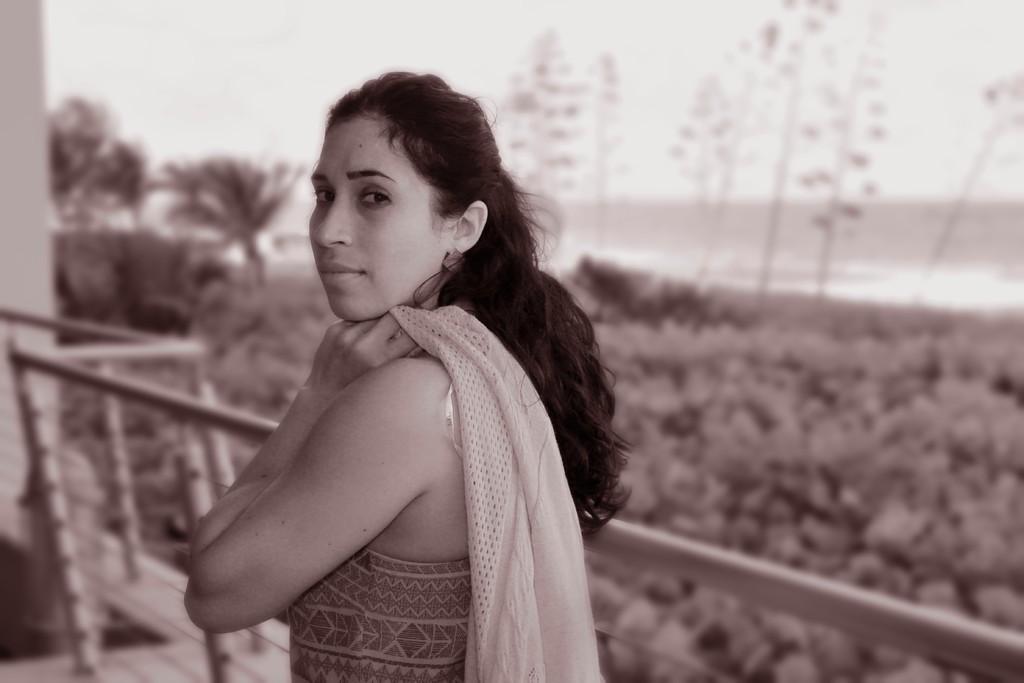Describe this image in one or two sentences. In the image in the center, we can see one woman standing and holding the cloth. In the background, we can see the sky, trees and fence. 